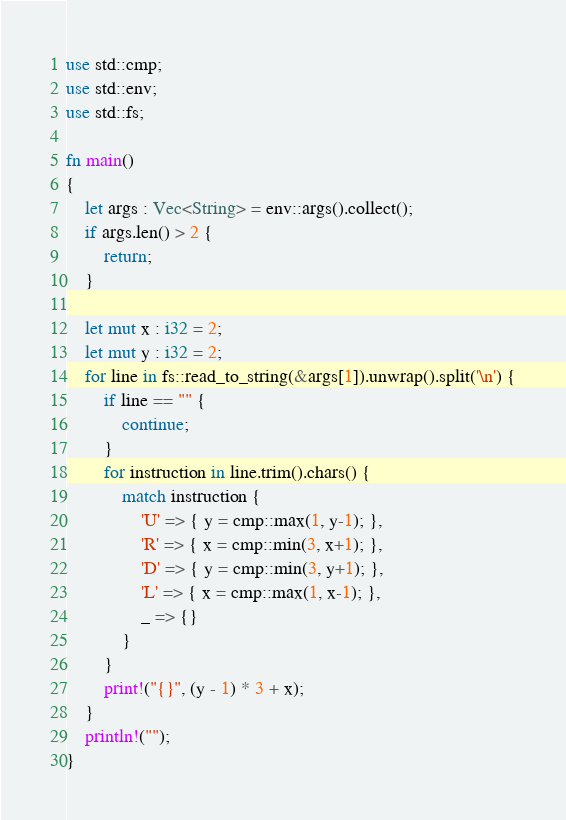<code> <loc_0><loc_0><loc_500><loc_500><_Rust_>use std::cmp;
use std::env;
use std::fs;

fn main() 
{
    let args : Vec<String> = env::args().collect();
    if args.len() > 2 {
        return;
    }

    let mut x : i32 = 2;
    let mut y : i32 = 2;
    for line in fs::read_to_string(&args[1]).unwrap().split('\n') {
        if line == "" {
            continue;
        }
        for instruction in line.trim().chars() {
            match instruction {
                'U' => { y = cmp::max(1, y-1); },
                'R' => { x = cmp::min(3, x+1); },
                'D' => { y = cmp::min(3, y+1); },
                'L' => { x = cmp::max(1, x-1); },
                _ => {}
            }
        }
        print!("{}", (y - 1) * 3 + x);
    }
    println!("");
}

</code> 